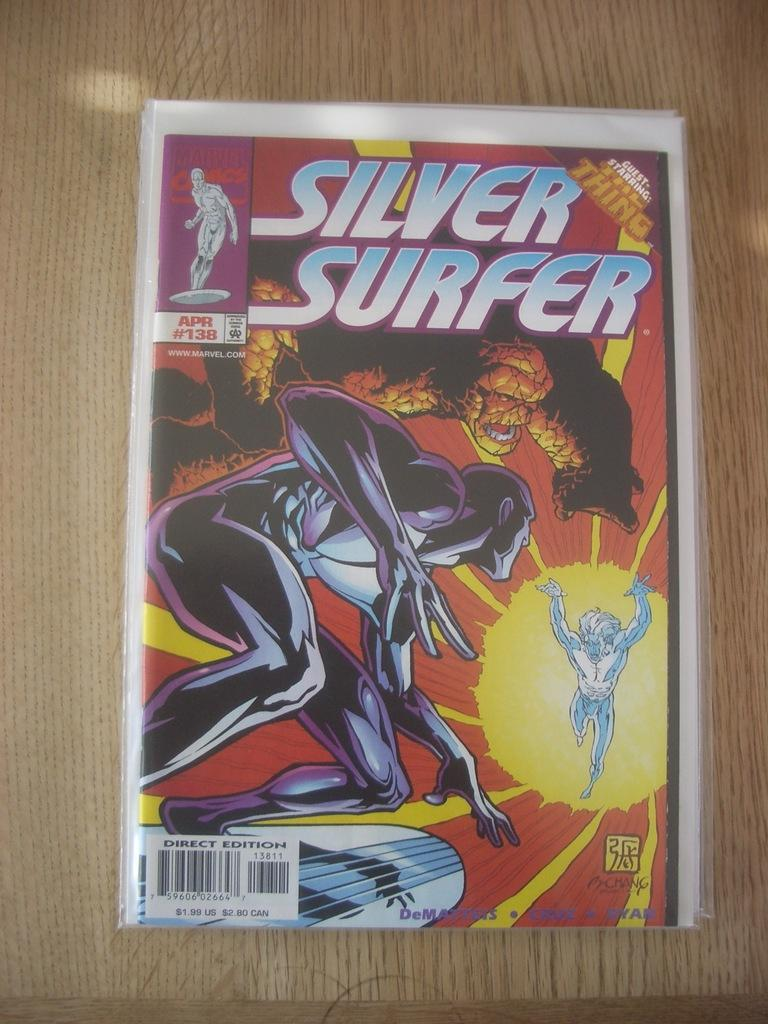What is the main object in the image? There is a book in the image. Where is the book located? The book is placed on a wooden object. How many cattle are grazing in the background of the image? There are no cattle present in the image; it only features a book placed on a wooden object. 